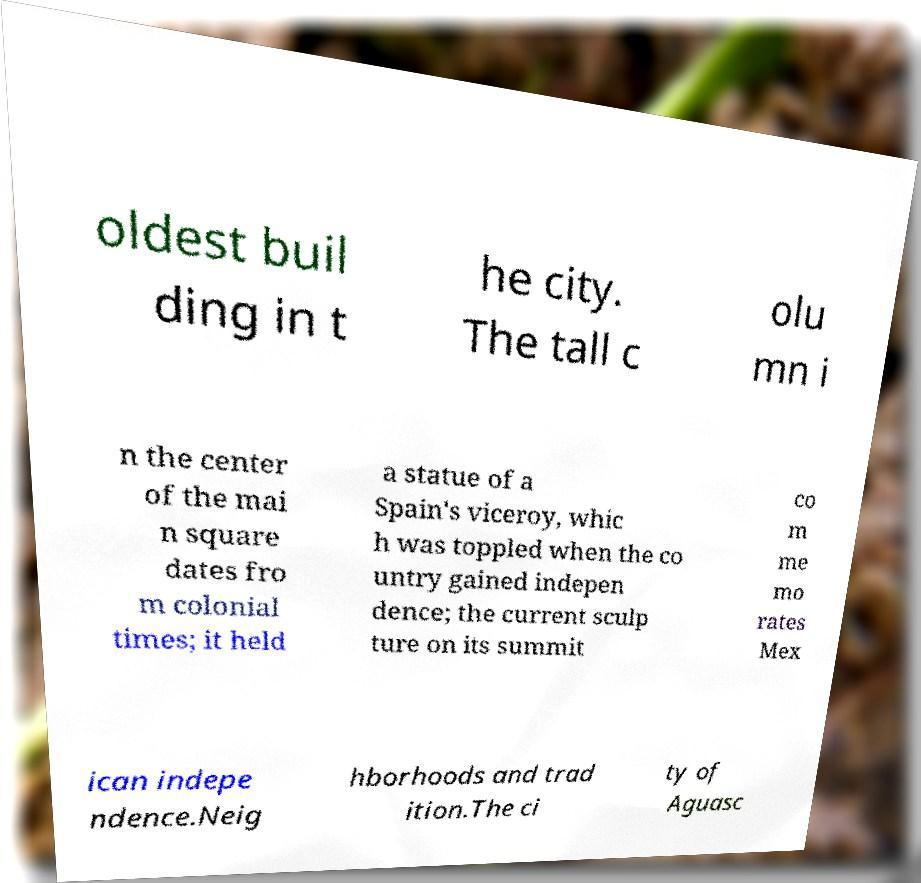I need the written content from this picture converted into text. Can you do that? oldest buil ding in t he city. The tall c olu mn i n the center of the mai n square dates fro m colonial times; it held a statue of a Spain's viceroy, whic h was toppled when the co untry gained indepen dence; the current sculp ture on its summit co m me mo rates Mex ican indepe ndence.Neig hborhoods and trad ition.The ci ty of Aguasc 